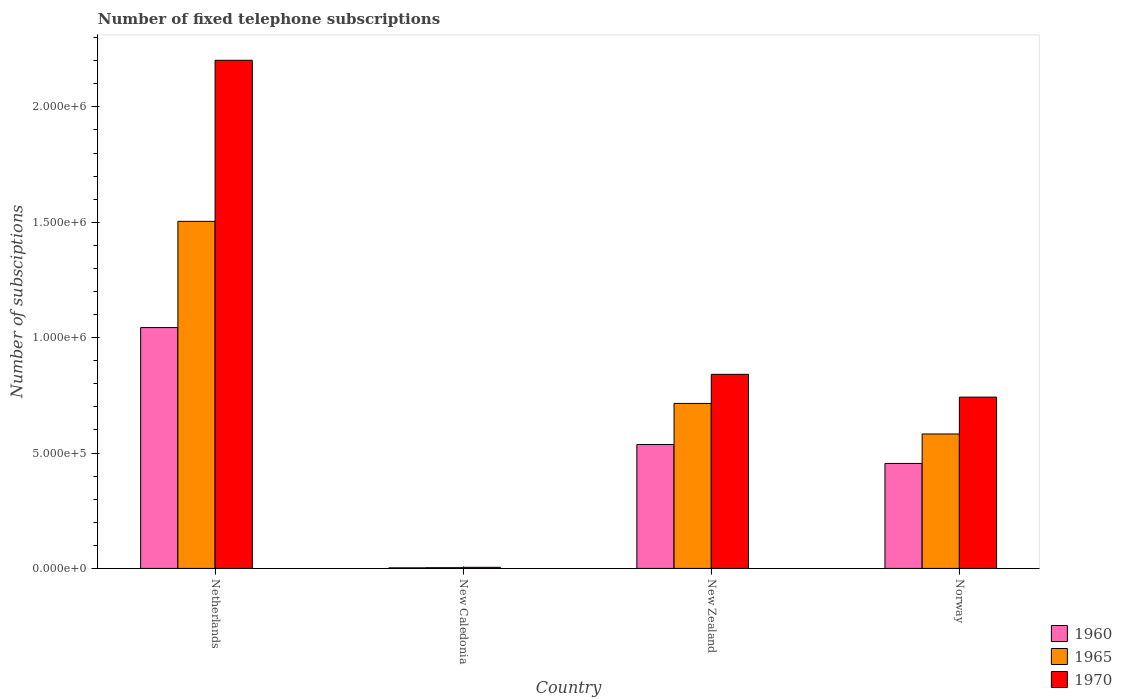How many groups of bars are there?
Offer a very short reply. 4. What is the label of the 2nd group of bars from the left?
Your response must be concise. New Caledonia. What is the number of fixed telephone subscriptions in 1965 in Netherlands?
Provide a succinct answer. 1.50e+06. Across all countries, what is the maximum number of fixed telephone subscriptions in 1965?
Your answer should be very brief. 1.50e+06. Across all countries, what is the minimum number of fixed telephone subscriptions in 1960?
Ensure brevity in your answer.  2394. In which country was the number of fixed telephone subscriptions in 1970 minimum?
Make the answer very short. New Caledonia. What is the total number of fixed telephone subscriptions in 1965 in the graph?
Keep it short and to the point. 2.80e+06. What is the difference between the number of fixed telephone subscriptions in 1970 in Netherlands and that in New Zealand?
Provide a short and direct response. 1.36e+06. What is the difference between the number of fixed telephone subscriptions in 1970 in Netherlands and the number of fixed telephone subscriptions in 1965 in New Zealand?
Provide a short and direct response. 1.49e+06. What is the average number of fixed telephone subscriptions in 1970 per country?
Your answer should be compact. 9.48e+05. What is the difference between the number of fixed telephone subscriptions of/in 1970 and number of fixed telephone subscriptions of/in 1965 in Norway?
Provide a succinct answer. 1.60e+05. In how many countries, is the number of fixed telephone subscriptions in 1965 greater than 400000?
Provide a short and direct response. 3. What is the ratio of the number of fixed telephone subscriptions in 1970 in New Zealand to that in Norway?
Ensure brevity in your answer.  1.13. Is the difference between the number of fixed telephone subscriptions in 1970 in New Caledonia and Norway greater than the difference between the number of fixed telephone subscriptions in 1965 in New Caledonia and Norway?
Provide a short and direct response. No. What is the difference between the highest and the second highest number of fixed telephone subscriptions in 1960?
Ensure brevity in your answer.  5.07e+05. What is the difference between the highest and the lowest number of fixed telephone subscriptions in 1960?
Provide a succinct answer. 1.04e+06. What does the 2nd bar from the left in Netherlands represents?
Provide a short and direct response. 1965. How many bars are there?
Keep it short and to the point. 12. Does the graph contain any zero values?
Your answer should be very brief. No. Does the graph contain grids?
Offer a very short reply. No. Where does the legend appear in the graph?
Keep it short and to the point. Bottom right. How many legend labels are there?
Ensure brevity in your answer.  3. How are the legend labels stacked?
Your answer should be compact. Vertical. What is the title of the graph?
Your answer should be very brief. Number of fixed telephone subscriptions. What is the label or title of the Y-axis?
Your response must be concise. Number of subsciptions. What is the Number of subsciptions in 1960 in Netherlands?
Your answer should be very brief. 1.04e+06. What is the Number of subsciptions of 1965 in Netherlands?
Your answer should be compact. 1.50e+06. What is the Number of subsciptions of 1970 in Netherlands?
Make the answer very short. 2.20e+06. What is the Number of subsciptions of 1960 in New Caledonia?
Offer a terse response. 2394. What is the Number of subsciptions of 1965 in New Caledonia?
Provide a succinct answer. 3100. What is the Number of subsciptions in 1970 in New Caledonia?
Ensure brevity in your answer.  4700. What is the Number of subsciptions of 1960 in New Zealand?
Provide a short and direct response. 5.37e+05. What is the Number of subsciptions in 1965 in New Zealand?
Keep it short and to the point. 7.15e+05. What is the Number of subsciptions in 1970 in New Zealand?
Your answer should be very brief. 8.41e+05. What is the Number of subsciptions in 1960 in Norway?
Your response must be concise. 4.55e+05. What is the Number of subsciptions of 1965 in Norway?
Offer a terse response. 5.83e+05. What is the Number of subsciptions of 1970 in Norway?
Offer a very short reply. 7.42e+05. Across all countries, what is the maximum Number of subsciptions in 1960?
Make the answer very short. 1.04e+06. Across all countries, what is the maximum Number of subsciptions in 1965?
Keep it short and to the point. 1.50e+06. Across all countries, what is the maximum Number of subsciptions of 1970?
Keep it short and to the point. 2.20e+06. Across all countries, what is the minimum Number of subsciptions of 1960?
Your response must be concise. 2394. Across all countries, what is the minimum Number of subsciptions of 1965?
Make the answer very short. 3100. Across all countries, what is the minimum Number of subsciptions in 1970?
Offer a very short reply. 4700. What is the total Number of subsciptions in 1960 in the graph?
Provide a short and direct response. 2.04e+06. What is the total Number of subsciptions in 1965 in the graph?
Make the answer very short. 2.80e+06. What is the total Number of subsciptions in 1970 in the graph?
Your answer should be compact. 3.79e+06. What is the difference between the Number of subsciptions of 1960 in Netherlands and that in New Caledonia?
Keep it short and to the point. 1.04e+06. What is the difference between the Number of subsciptions in 1965 in Netherlands and that in New Caledonia?
Keep it short and to the point. 1.50e+06. What is the difference between the Number of subsciptions in 1970 in Netherlands and that in New Caledonia?
Your response must be concise. 2.20e+06. What is the difference between the Number of subsciptions of 1960 in Netherlands and that in New Zealand?
Keep it short and to the point. 5.07e+05. What is the difference between the Number of subsciptions of 1965 in Netherlands and that in New Zealand?
Your response must be concise. 7.89e+05. What is the difference between the Number of subsciptions of 1970 in Netherlands and that in New Zealand?
Your answer should be very brief. 1.36e+06. What is the difference between the Number of subsciptions of 1960 in Netherlands and that in Norway?
Offer a very short reply. 5.89e+05. What is the difference between the Number of subsciptions of 1965 in Netherlands and that in Norway?
Offer a terse response. 9.21e+05. What is the difference between the Number of subsciptions of 1970 in Netherlands and that in Norway?
Make the answer very short. 1.46e+06. What is the difference between the Number of subsciptions in 1960 in New Caledonia and that in New Zealand?
Keep it short and to the point. -5.35e+05. What is the difference between the Number of subsciptions of 1965 in New Caledonia and that in New Zealand?
Your response must be concise. -7.12e+05. What is the difference between the Number of subsciptions of 1970 in New Caledonia and that in New Zealand?
Keep it short and to the point. -8.36e+05. What is the difference between the Number of subsciptions of 1960 in New Caledonia and that in Norway?
Ensure brevity in your answer.  -4.53e+05. What is the difference between the Number of subsciptions in 1965 in New Caledonia and that in Norway?
Your answer should be compact. -5.80e+05. What is the difference between the Number of subsciptions of 1970 in New Caledonia and that in Norway?
Your answer should be compact. -7.38e+05. What is the difference between the Number of subsciptions in 1960 in New Zealand and that in Norway?
Offer a terse response. 8.21e+04. What is the difference between the Number of subsciptions of 1965 in New Zealand and that in Norway?
Make the answer very short. 1.32e+05. What is the difference between the Number of subsciptions in 1970 in New Zealand and that in Norway?
Ensure brevity in your answer.  9.87e+04. What is the difference between the Number of subsciptions in 1960 in Netherlands and the Number of subsciptions in 1965 in New Caledonia?
Your response must be concise. 1.04e+06. What is the difference between the Number of subsciptions in 1960 in Netherlands and the Number of subsciptions in 1970 in New Caledonia?
Your answer should be compact. 1.04e+06. What is the difference between the Number of subsciptions in 1965 in Netherlands and the Number of subsciptions in 1970 in New Caledonia?
Offer a very short reply. 1.50e+06. What is the difference between the Number of subsciptions of 1960 in Netherlands and the Number of subsciptions of 1965 in New Zealand?
Keep it short and to the point. 3.29e+05. What is the difference between the Number of subsciptions in 1960 in Netherlands and the Number of subsciptions in 1970 in New Zealand?
Your response must be concise. 2.03e+05. What is the difference between the Number of subsciptions of 1965 in Netherlands and the Number of subsciptions of 1970 in New Zealand?
Offer a terse response. 6.63e+05. What is the difference between the Number of subsciptions in 1960 in Netherlands and the Number of subsciptions in 1965 in Norway?
Offer a very short reply. 4.61e+05. What is the difference between the Number of subsciptions of 1960 in Netherlands and the Number of subsciptions of 1970 in Norway?
Give a very brief answer. 3.01e+05. What is the difference between the Number of subsciptions in 1965 in Netherlands and the Number of subsciptions in 1970 in Norway?
Make the answer very short. 7.62e+05. What is the difference between the Number of subsciptions of 1960 in New Caledonia and the Number of subsciptions of 1965 in New Zealand?
Keep it short and to the point. -7.13e+05. What is the difference between the Number of subsciptions of 1960 in New Caledonia and the Number of subsciptions of 1970 in New Zealand?
Your answer should be very brief. -8.39e+05. What is the difference between the Number of subsciptions in 1965 in New Caledonia and the Number of subsciptions in 1970 in New Zealand?
Your answer should be compact. -8.38e+05. What is the difference between the Number of subsciptions of 1960 in New Caledonia and the Number of subsciptions of 1965 in Norway?
Give a very brief answer. -5.80e+05. What is the difference between the Number of subsciptions of 1960 in New Caledonia and the Number of subsciptions of 1970 in Norway?
Your answer should be very brief. -7.40e+05. What is the difference between the Number of subsciptions in 1965 in New Caledonia and the Number of subsciptions in 1970 in Norway?
Ensure brevity in your answer.  -7.39e+05. What is the difference between the Number of subsciptions of 1960 in New Zealand and the Number of subsciptions of 1965 in Norway?
Keep it short and to the point. -4.56e+04. What is the difference between the Number of subsciptions in 1960 in New Zealand and the Number of subsciptions in 1970 in Norway?
Your answer should be compact. -2.05e+05. What is the difference between the Number of subsciptions in 1965 in New Zealand and the Number of subsciptions in 1970 in Norway?
Your response must be concise. -2.73e+04. What is the average Number of subsciptions in 1960 per country?
Give a very brief answer. 5.09e+05. What is the average Number of subsciptions of 1965 per country?
Offer a terse response. 7.01e+05. What is the average Number of subsciptions in 1970 per country?
Offer a terse response. 9.48e+05. What is the difference between the Number of subsciptions in 1960 and Number of subsciptions in 1965 in Netherlands?
Offer a very short reply. -4.60e+05. What is the difference between the Number of subsciptions of 1960 and Number of subsciptions of 1970 in Netherlands?
Give a very brief answer. -1.16e+06. What is the difference between the Number of subsciptions of 1965 and Number of subsciptions of 1970 in Netherlands?
Provide a short and direct response. -6.98e+05. What is the difference between the Number of subsciptions of 1960 and Number of subsciptions of 1965 in New Caledonia?
Ensure brevity in your answer.  -706. What is the difference between the Number of subsciptions in 1960 and Number of subsciptions in 1970 in New Caledonia?
Your response must be concise. -2306. What is the difference between the Number of subsciptions in 1965 and Number of subsciptions in 1970 in New Caledonia?
Your answer should be compact. -1600. What is the difference between the Number of subsciptions of 1960 and Number of subsciptions of 1965 in New Zealand?
Your response must be concise. -1.78e+05. What is the difference between the Number of subsciptions in 1960 and Number of subsciptions in 1970 in New Zealand?
Offer a terse response. -3.04e+05. What is the difference between the Number of subsciptions of 1965 and Number of subsciptions of 1970 in New Zealand?
Offer a very short reply. -1.26e+05. What is the difference between the Number of subsciptions in 1960 and Number of subsciptions in 1965 in Norway?
Your answer should be compact. -1.28e+05. What is the difference between the Number of subsciptions of 1960 and Number of subsciptions of 1970 in Norway?
Your response must be concise. -2.87e+05. What is the difference between the Number of subsciptions in 1965 and Number of subsciptions in 1970 in Norway?
Your answer should be compact. -1.60e+05. What is the ratio of the Number of subsciptions of 1960 in Netherlands to that in New Caledonia?
Provide a short and direct response. 435.95. What is the ratio of the Number of subsciptions of 1965 in Netherlands to that in New Caledonia?
Offer a very short reply. 485.16. What is the ratio of the Number of subsciptions of 1970 in Netherlands to that in New Caledonia?
Ensure brevity in your answer.  468.51. What is the ratio of the Number of subsciptions of 1960 in Netherlands to that in New Zealand?
Give a very brief answer. 1.94. What is the ratio of the Number of subsciptions in 1965 in Netherlands to that in New Zealand?
Make the answer very short. 2.1. What is the ratio of the Number of subsciptions in 1970 in Netherlands to that in New Zealand?
Keep it short and to the point. 2.62. What is the ratio of the Number of subsciptions in 1960 in Netherlands to that in Norway?
Offer a terse response. 2.29. What is the ratio of the Number of subsciptions of 1965 in Netherlands to that in Norway?
Provide a short and direct response. 2.58. What is the ratio of the Number of subsciptions of 1970 in Netherlands to that in Norway?
Your answer should be compact. 2.97. What is the ratio of the Number of subsciptions in 1960 in New Caledonia to that in New Zealand?
Offer a very short reply. 0. What is the ratio of the Number of subsciptions in 1965 in New Caledonia to that in New Zealand?
Make the answer very short. 0. What is the ratio of the Number of subsciptions of 1970 in New Caledonia to that in New Zealand?
Offer a terse response. 0.01. What is the ratio of the Number of subsciptions in 1960 in New Caledonia to that in Norway?
Ensure brevity in your answer.  0.01. What is the ratio of the Number of subsciptions of 1965 in New Caledonia to that in Norway?
Your answer should be compact. 0.01. What is the ratio of the Number of subsciptions of 1970 in New Caledonia to that in Norway?
Provide a succinct answer. 0.01. What is the ratio of the Number of subsciptions of 1960 in New Zealand to that in Norway?
Offer a very short reply. 1.18. What is the ratio of the Number of subsciptions of 1965 in New Zealand to that in Norway?
Offer a terse response. 1.23. What is the ratio of the Number of subsciptions in 1970 in New Zealand to that in Norway?
Your response must be concise. 1.13. What is the difference between the highest and the second highest Number of subsciptions of 1960?
Offer a terse response. 5.07e+05. What is the difference between the highest and the second highest Number of subsciptions in 1965?
Give a very brief answer. 7.89e+05. What is the difference between the highest and the second highest Number of subsciptions of 1970?
Your answer should be very brief. 1.36e+06. What is the difference between the highest and the lowest Number of subsciptions in 1960?
Provide a succinct answer. 1.04e+06. What is the difference between the highest and the lowest Number of subsciptions of 1965?
Your answer should be compact. 1.50e+06. What is the difference between the highest and the lowest Number of subsciptions in 1970?
Keep it short and to the point. 2.20e+06. 